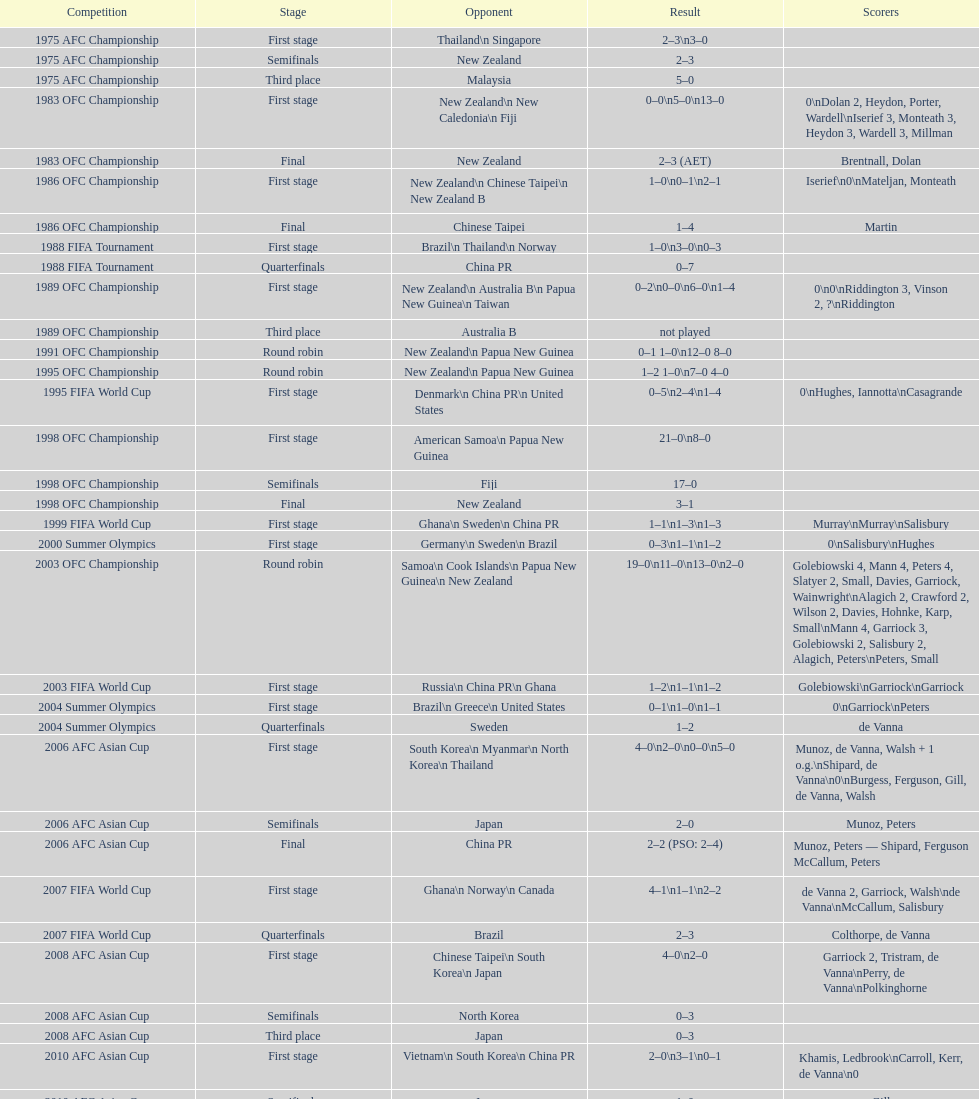How many players scored during the 1983 ofc championship competition? 9. 